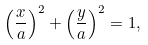Convert formula to latex. <formula><loc_0><loc_0><loc_500><loc_500>\left ( { \frac { x } { a } } \right ) ^ { 2 } + \left ( { \frac { y } { a } } \right ) ^ { 2 } = 1 ,</formula> 